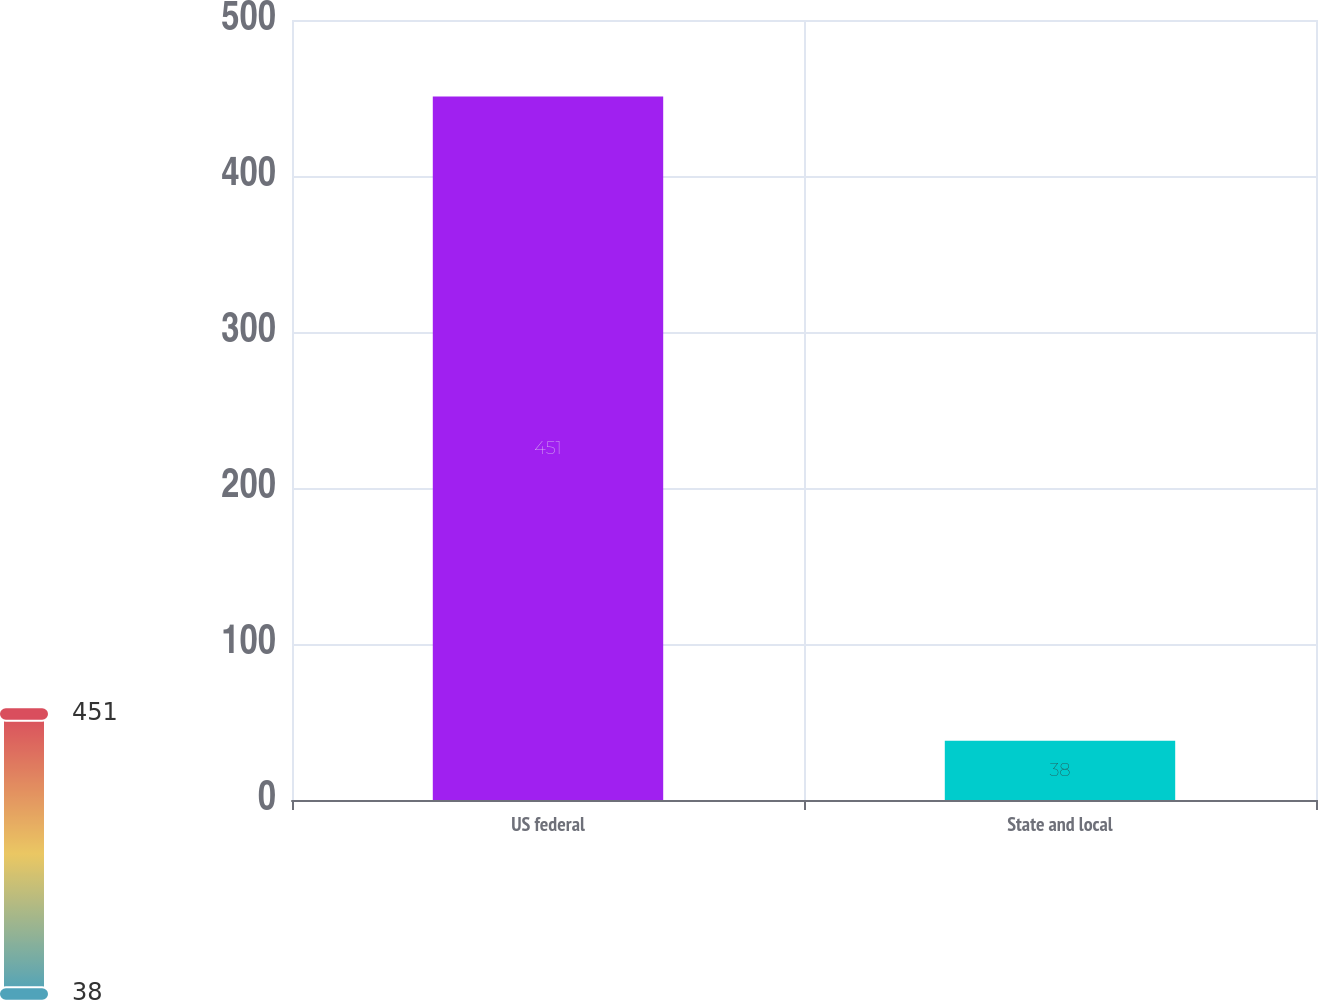<chart> <loc_0><loc_0><loc_500><loc_500><bar_chart><fcel>US federal<fcel>State and local<nl><fcel>451<fcel>38<nl></chart> 